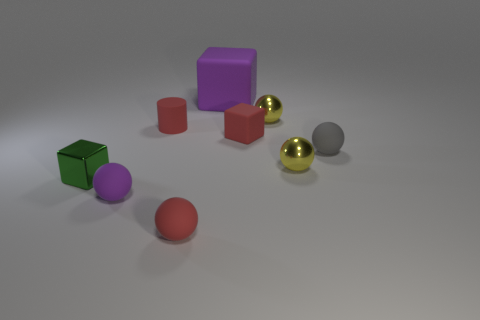Subtract all tiny red matte blocks. How many blocks are left? 2 Subtract all gray blocks. How many yellow balls are left? 2 Subtract all yellow balls. How many balls are left? 3 Subtract 1 cubes. How many cubes are left? 2 Add 1 spheres. How many objects exist? 10 Subtract all cylinders. How many objects are left? 8 Subtract all gray balls. Subtract all brown blocks. How many balls are left? 4 Subtract all purple metallic blocks. Subtract all large matte things. How many objects are left? 8 Add 4 purple objects. How many purple objects are left? 6 Add 2 small green shiny objects. How many small green shiny objects exist? 3 